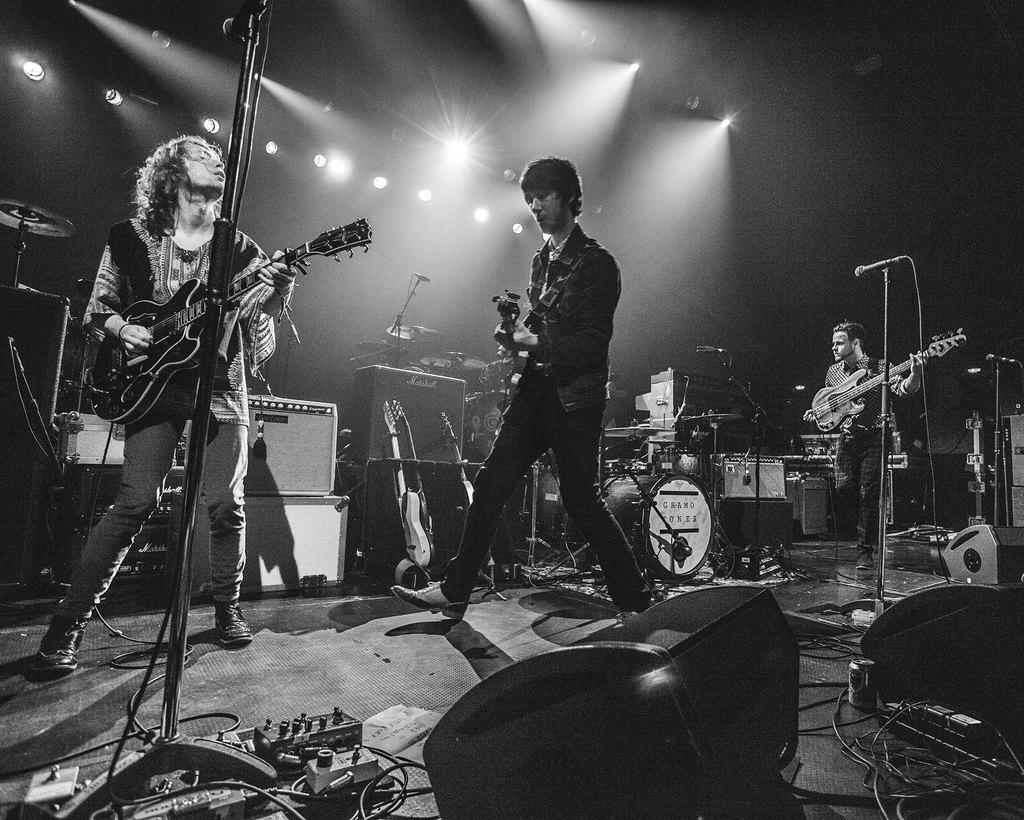How many people are in the image? There are three persons in the image. What are the persons doing in the image? The persons are playing musical instruments. What can be seen in the background of the image? There are lights in the background of the image. What type of throat lozenges are the persons using while playing their instruments in the image? There is no indication in the image that the persons are using throat lozenges or experiencing any throat-related issues. 